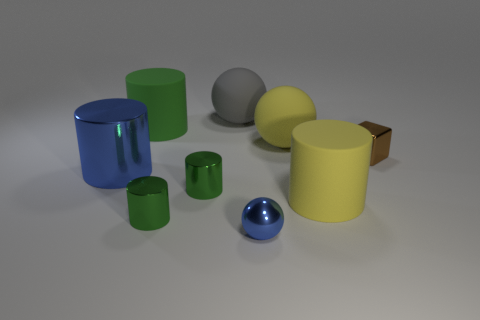Subtract all blue metallic balls. How many balls are left? 2 Subtract all green blocks. How many green cylinders are left? 3 Subtract all yellow cylinders. How many cylinders are left? 4 Subtract all purple spheres. Subtract all cyan cylinders. How many spheres are left? 3 Add 1 big balls. How many objects exist? 10 Subtract all cubes. How many objects are left? 8 Subtract 0 red cylinders. How many objects are left? 9 Subtract all small blue spheres. Subtract all yellow matte things. How many objects are left? 6 Add 5 gray balls. How many gray balls are left? 6 Add 9 small red shiny objects. How many small red shiny objects exist? 9 